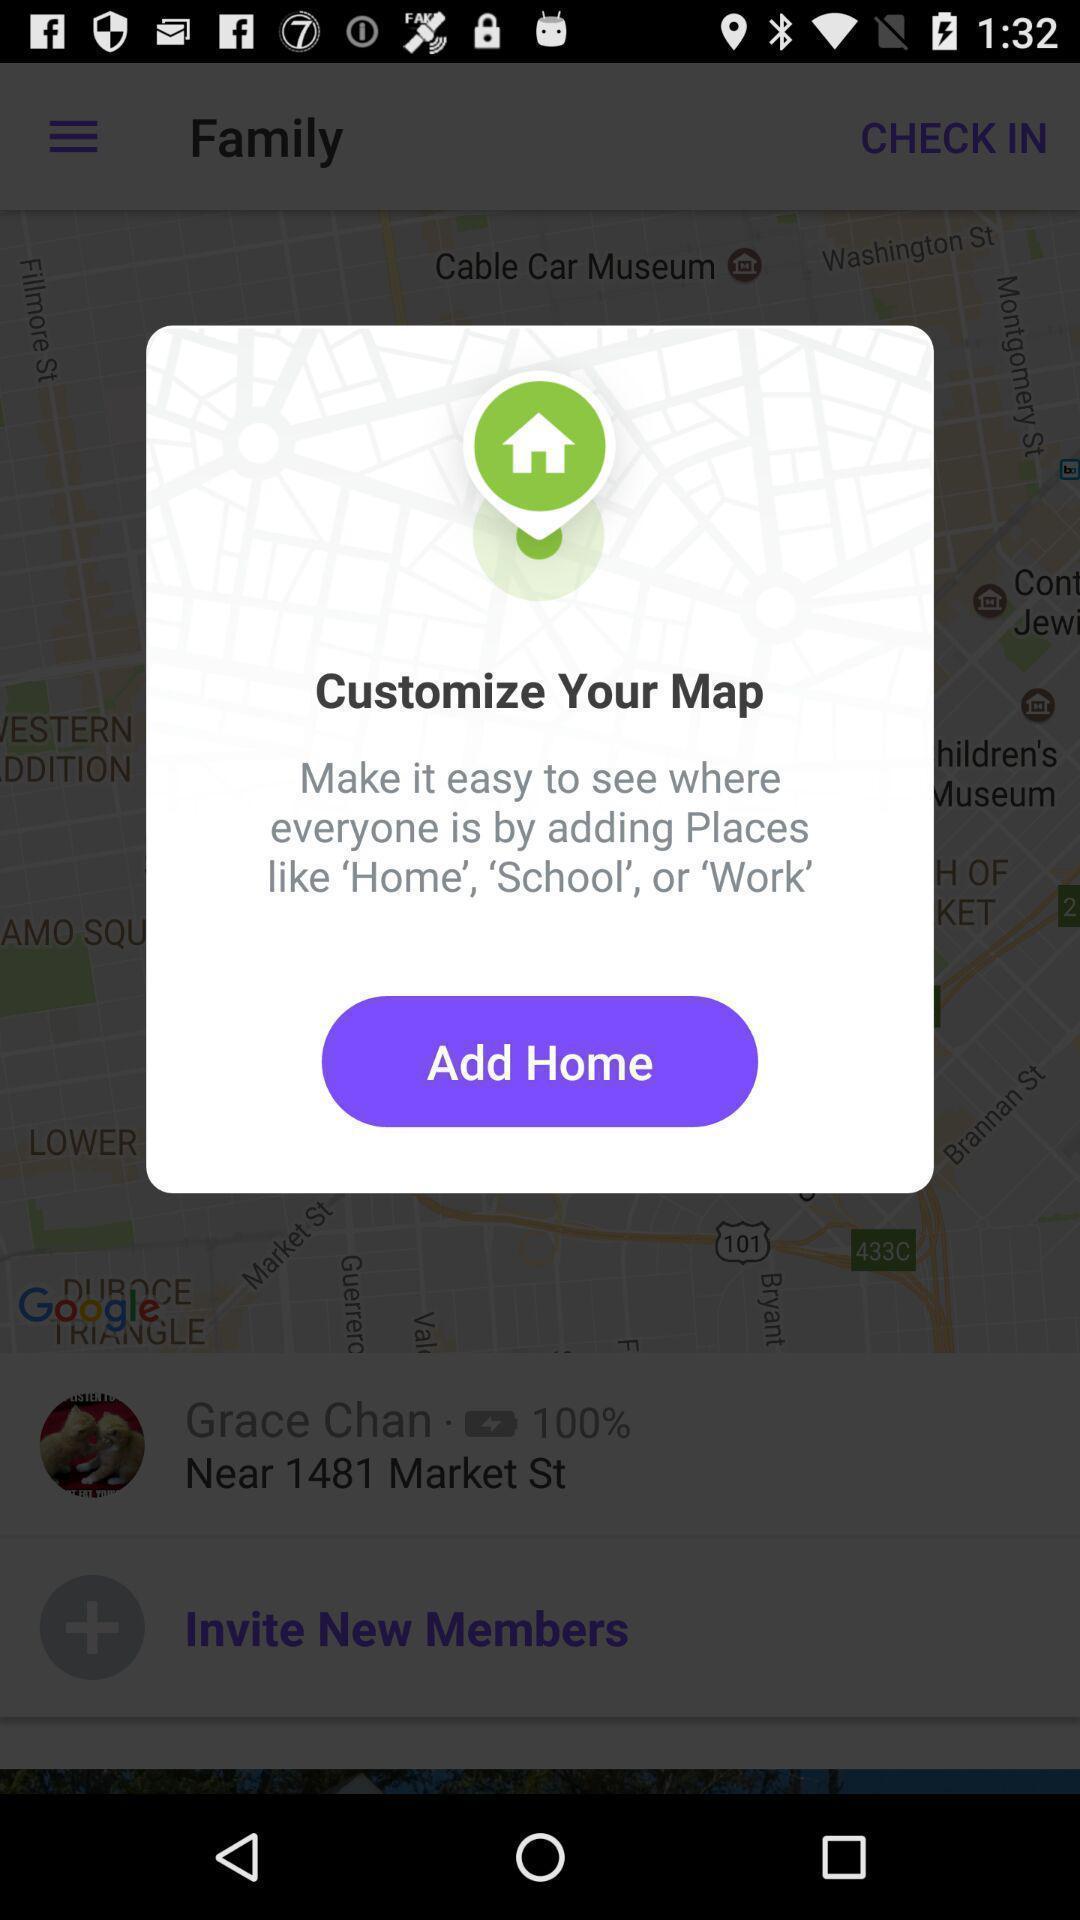What can you discern from this picture? Pop-up showing information about navigator app. 